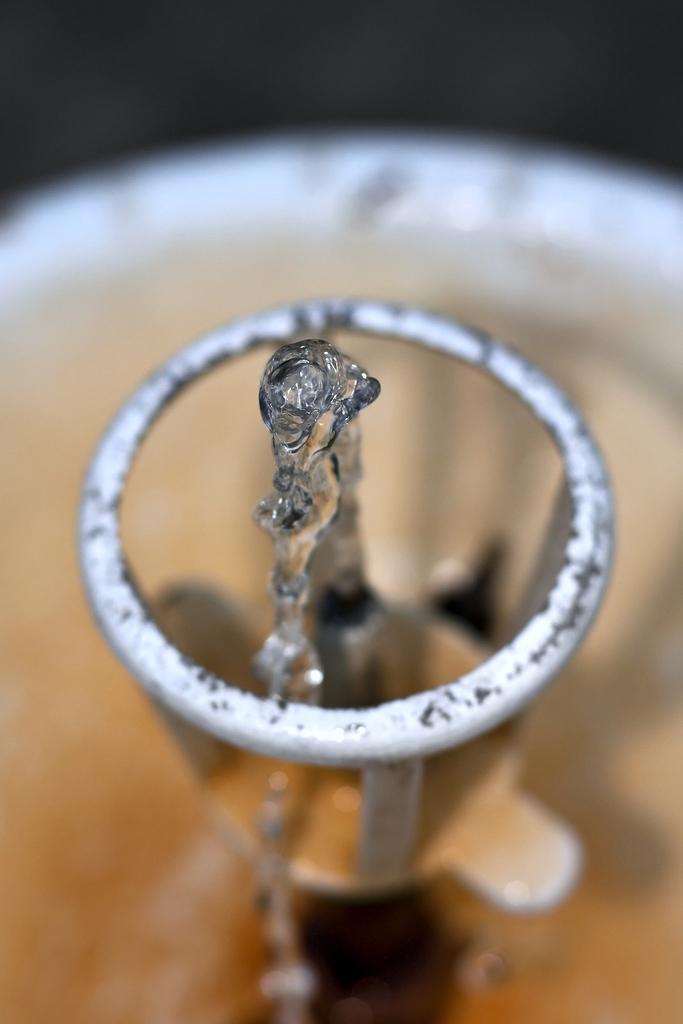Describe this image in one or two sentences. This is a zoomed in picture of a water sprinkler. 